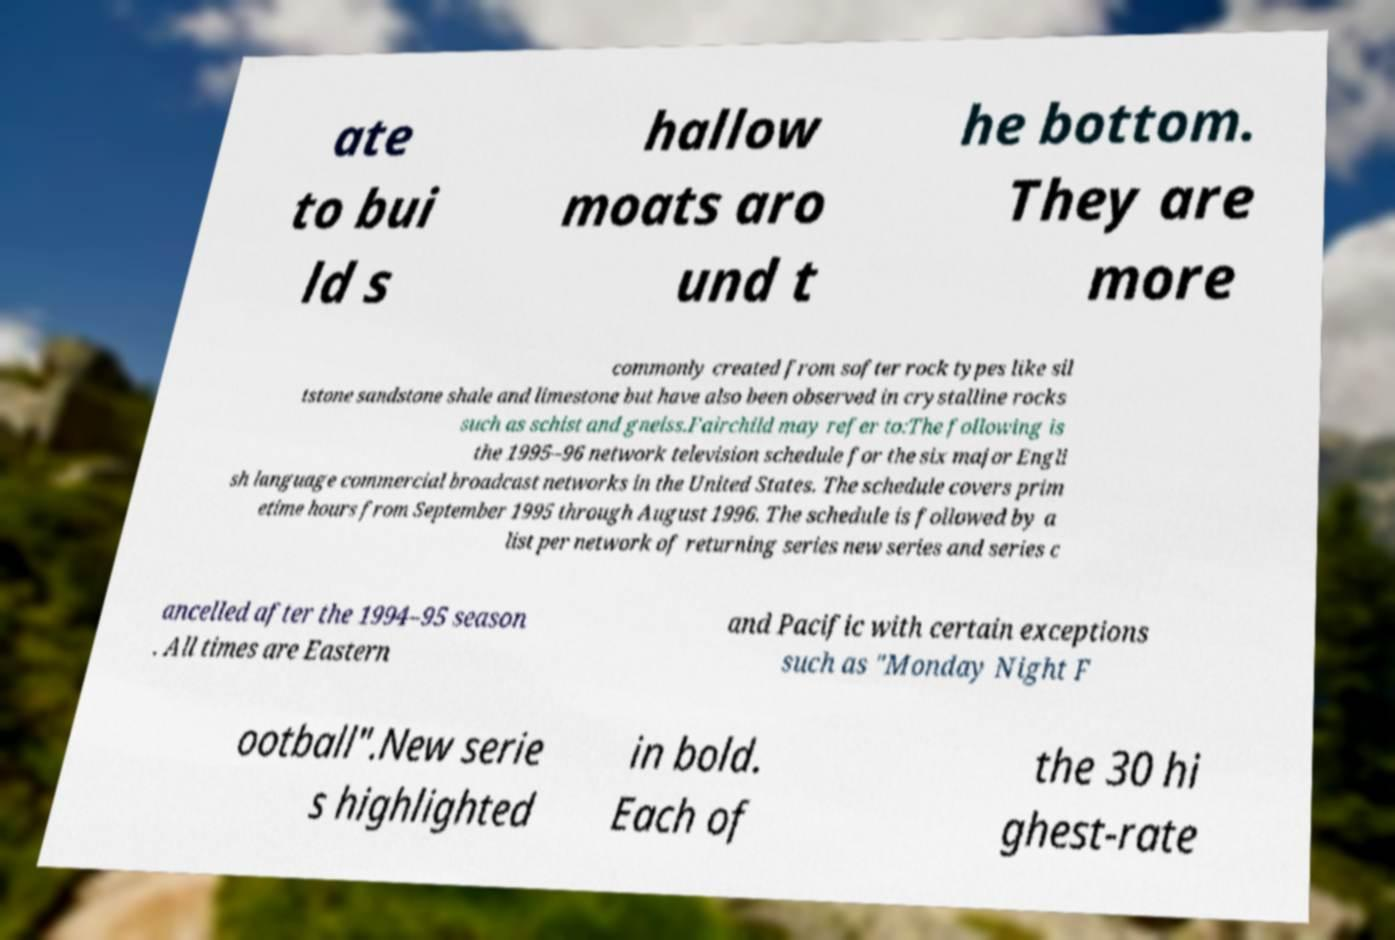I need the written content from this picture converted into text. Can you do that? ate to bui ld s hallow moats aro und t he bottom. They are more commonly created from softer rock types like sil tstone sandstone shale and limestone but have also been observed in crystalline rocks such as schist and gneiss.Fairchild may refer to:The following is the 1995–96 network television schedule for the six major Engli sh language commercial broadcast networks in the United States. The schedule covers prim etime hours from September 1995 through August 1996. The schedule is followed by a list per network of returning series new series and series c ancelled after the 1994–95 season . All times are Eastern and Pacific with certain exceptions such as "Monday Night F ootball".New serie s highlighted in bold. Each of the 30 hi ghest-rate 